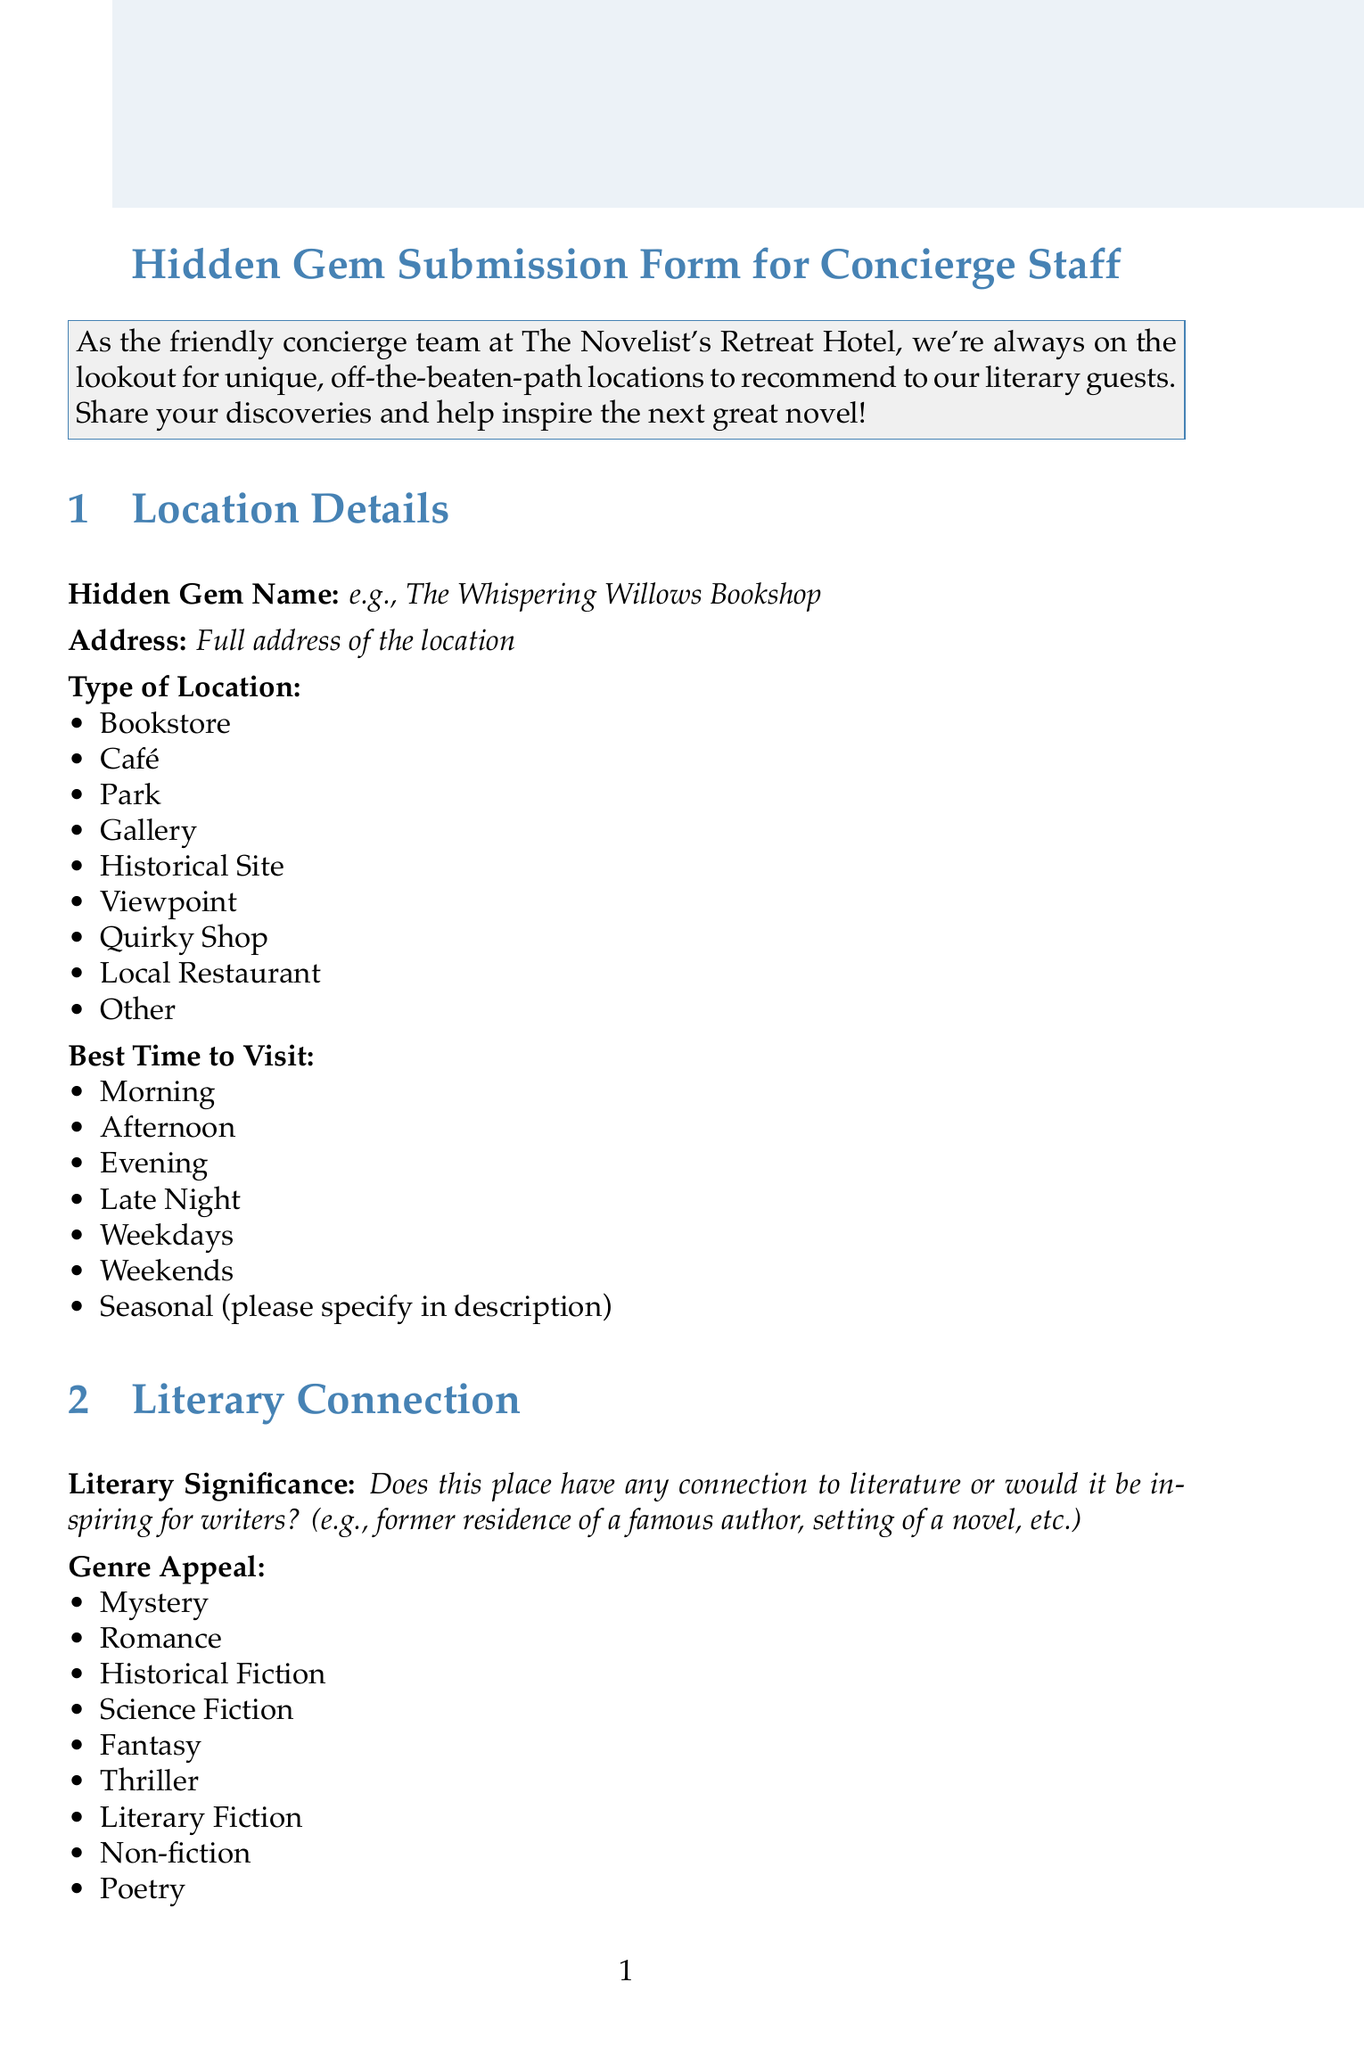what is the title of the form? The form title is clearly stated at the top of the document.
Answer: Hidden Gem Submission Form for Concierge Staff what is the required field for the hidden gem name? The document specifies that this field must be filled in to complete the submission.
Answer: e.g., The Whispering Willows Bookshop what types of locations can be selected from the dropdown? The options available in the dropdown for type of location are detailed in the document.
Answer: Bookstore, Café, Park, Gallery, Historical Site, Viewpoint, Quirky Shop, Local Restaurant, Other how many genres can be selected for genre appeal? The document lists the genres available for selection.
Answer: Nine what does the submitter need to provide for contact information? The document specifies fields related to contact that can be filled in by the submitter.
Answer: Contact Number what is the maximum rating that a submitter can give? This information is found in the section regarding personal rating.
Answer: 5 what kind of experience is described under the visitor experience section? The section outlines what should be detailed about the place being submitted.
Answer: Enticing description of the location and why it's special what is the message at the end of the document? The final note expresses gratitude towards the submitter for their contribution.
Answer: Thank you for sharing this hidden gem! what is the main purpose of this form? The initial description outlines the reason for collecting the hidden gem submissions.
Answer: To recommend unique, off-the-beaten-path locations to literary guests 